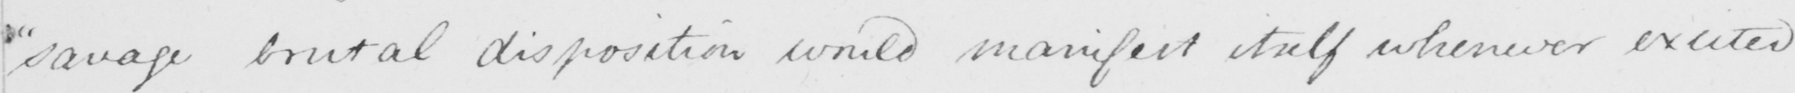What does this handwritten line say? " savage brutal dispostion would manifest itself whenever excited 